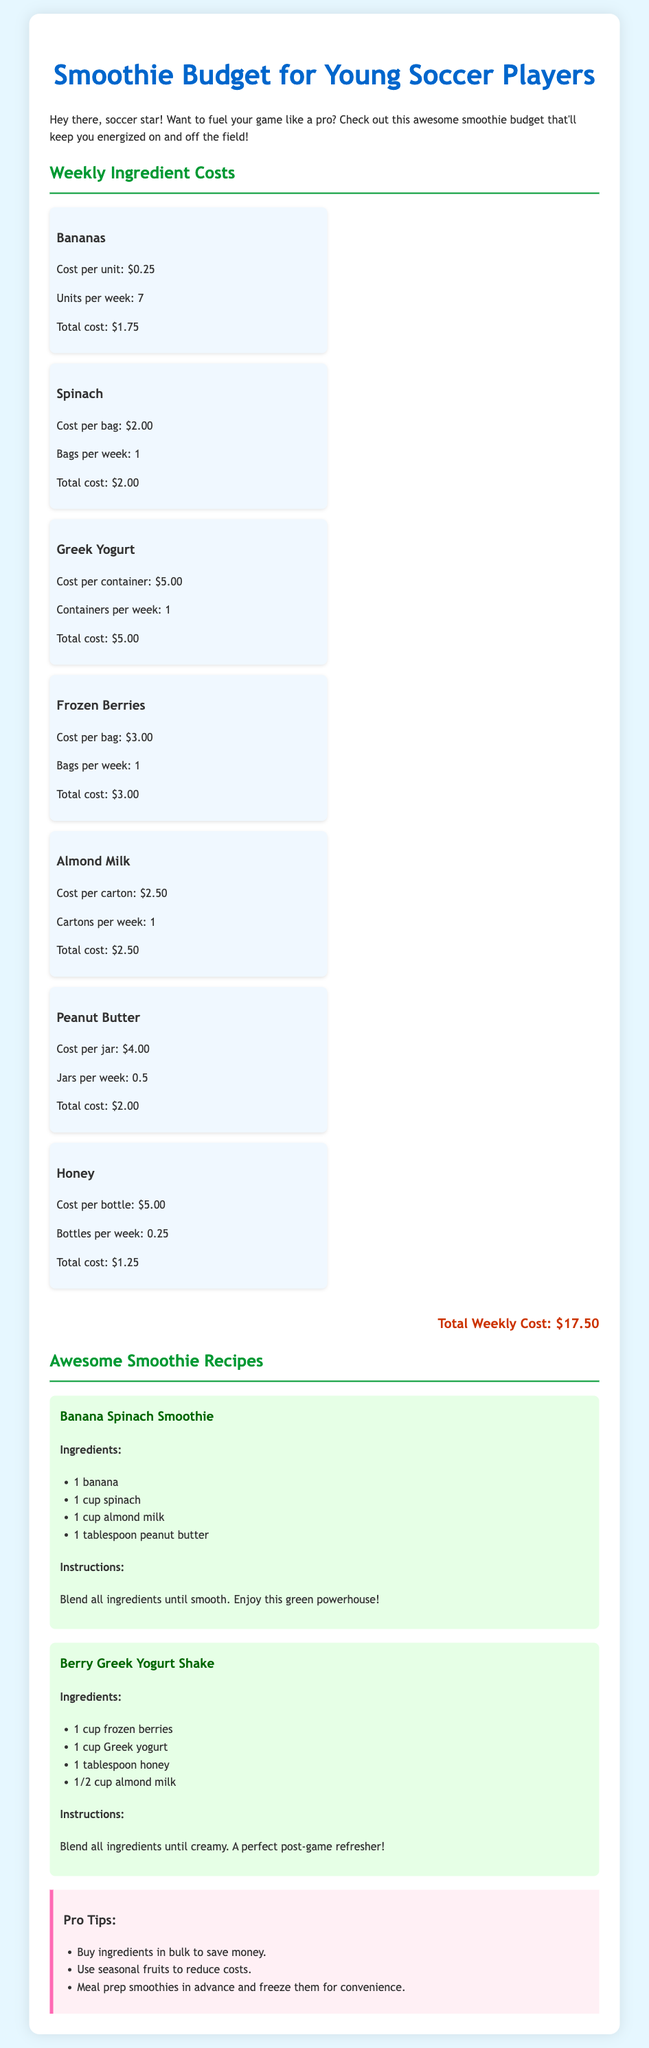what is the total weekly cost? The total weekly cost is displayed in the document at the end of the ingredient section, which is $17.50.
Answer: $17.50 how much does a banana cost per unit? The cost per unit of a banana is listed directly in the ingredient section, which shows $0.25.
Answer: $0.25 how many bags of spinach should be bought per week? The document specifies that 1 bag of spinach should be bought per week in the ingredient list.
Answer: 1 what is the main ingredient in the Berry Greek Yogurt Shake? The recipe for Berry Greek Yogurt Shake lists frozen berries as the first ingredient, indicating it as the main ingredient.
Answer: frozen berries how much honey is needed for one Berry Greek Yogurt Shake? The recipe indicates that 1 tablespoon of honey is required for the Berry Greek Yogurt Shake.
Answer: 1 tablespoon what are two pro tips provided in the document? The document lists several tips in the tips section; two of them include "Buy ingredients in bulk to save money" and "Use seasonal fruits to reduce costs."
Answer: Buy ingredients in bulk, Use seasonal fruits how many jars of peanut butter are needed per week? The ingredient list specifies that 0.5 jars of peanut butter should be bought each week.
Answer: 0.5 jars how many cups of spinach are used in the Banana Spinach Smoothie? The Banana Spinach Smoothie recipe calls for 1 cup of spinach, as listed in the ingredients section.
Answer: 1 cup what is the first step in making the Banana Spinach Smoothie? The instruction states to "Blend all ingredients until smooth," which is the first step in the preparation.
Answer: Blend all ingredients until smooth 